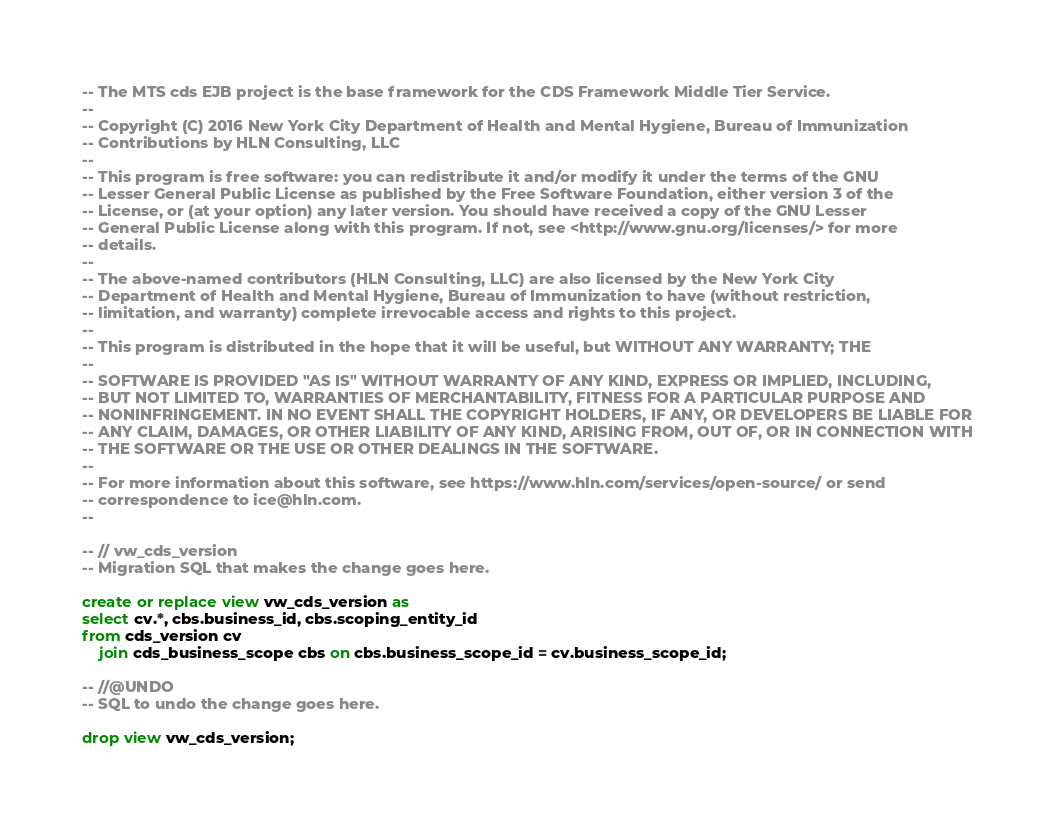<code> <loc_0><loc_0><loc_500><loc_500><_SQL_>-- The MTS cds EJB project is the base framework for the CDS Framework Middle Tier Service.
--
-- Copyright (C) 2016 New York City Department of Health and Mental Hygiene, Bureau of Immunization
-- Contributions by HLN Consulting, LLC
--
-- This program is free software: you can redistribute it and/or modify it under the terms of the GNU
-- Lesser General Public License as published by the Free Software Foundation, either version 3 of the
-- License, or (at your option) any later version. You should have received a copy of the GNU Lesser
-- General Public License along with this program. If not, see <http://www.gnu.org/licenses/> for more
-- details.
--
-- The above-named contributors (HLN Consulting, LLC) are also licensed by the New York City
-- Department of Health and Mental Hygiene, Bureau of Immunization to have (without restriction,
-- limitation, and warranty) complete irrevocable access and rights to this project.
--
-- This program is distributed in the hope that it will be useful, but WITHOUT ANY WARRANTY; THE
--
-- SOFTWARE IS PROVIDED "AS IS" WITHOUT WARRANTY OF ANY KIND, EXPRESS OR IMPLIED, INCLUDING,
-- BUT NOT LIMITED TO, WARRANTIES OF MERCHANTABILITY, FITNESS FOR A PARTICULAR PURPOSE AND
-- NONINFRINGEMENT. IN NO EVENT SHALL THE COPYRIGHT HOLDERS, IF ANY, OR DEVELOPERS BE LIABLE FOR
-- ANY CLAIM, DAMAGES, OR OTHER LIABILITY OF ANY KIND, ARISING FROM, OUT OF, OR IN CONNECTION WITH
-- THE SOFTWARE OR THE USE OR OTHER DEALINGS IN THE SOFTWARE.
--
-- For more information about this software, see https://www.hln.com/services/open-source/ or send
-- correspondence to ice@hln.com.
--

-- // vw_cds_version
-- Migration SQL that makes the change goes here.

create or replace view vw_cds_version as
select cv.*, cbs.business_id, cbs.scoping_entity_id
from cds_version cv
    join cds_business_scope cbs on cbs.business_scope_id = cv.business_scope_id;

-- //@UNDO
-- SQL to undo the change goes here.

drop view vw_cds_version;
</code> 